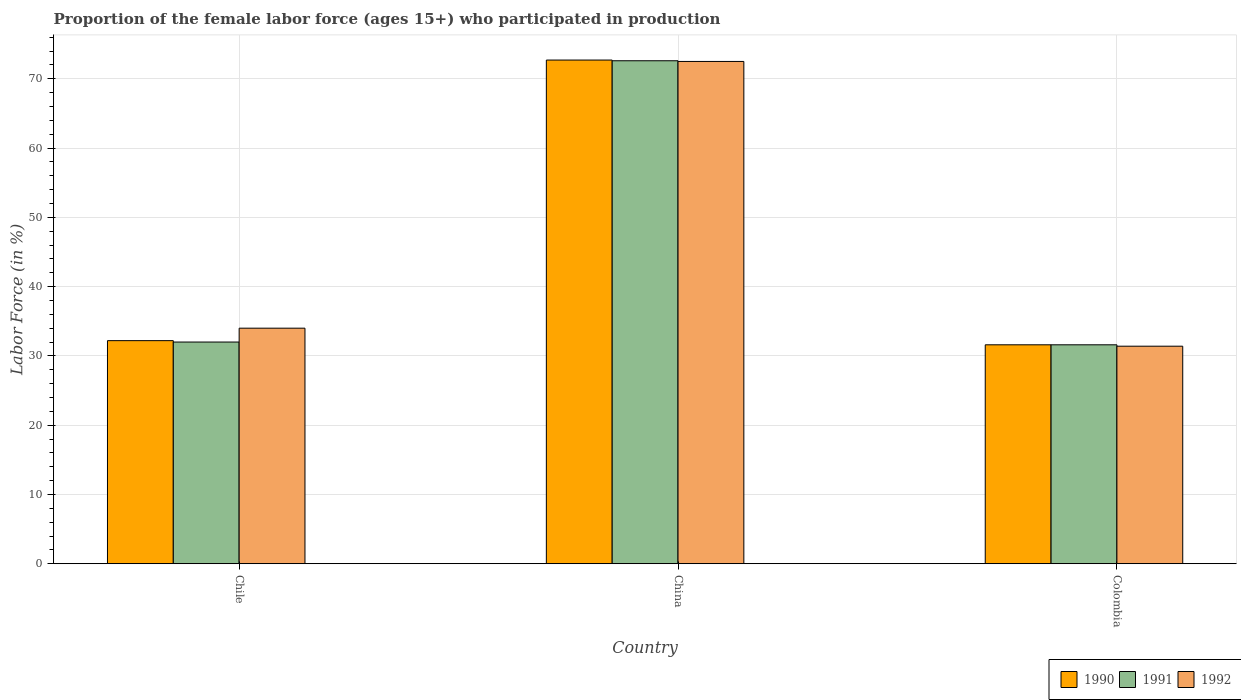Are the number of bars per tick equal to the number of legend labels?
Make the answer very short. Yes. Are the number of bars on each tick of the X-axis equal?
Your answer should be compact. Yes. How many bars are there on the 3rd tick from the right?
Provide a short and direct response. 3. Across all countries, what is the maximum proportion of the female labor force who participated in production in 1992?
Offer a very short reply. 72.5. Across all countries, what is the minimum proportion of the female labor force who participated in production in 1990?
Offer a terse response. 31.6. What is the total proportion of the female labor force who participated in production in 1992 in the graph?
Your answer should be very brief. 137.9. What is the difference between the proportion of the female labor force who participated in production in 1991 in Chile and that in Colombia?
Your response must be concise. 0.4. What is the difference between the proportion of the female labor force who participated in production in 1991 in Chile and the proportion of the female labor force who participated in production in 1992 in China?
Offer a very short reply. -40.5. What is the average proportion of the female labor force who participated in production in 1991 per country?
Your response must be concise. 45.4. What is the difference between the proportion of the female labor force who participated in production of/in 1991 and proportion of the female labor force who participated in production of/in 1992 in Colombia?
Your answer should be compact. 0.2. What is the ratio of the proportion of the female labor force who participated in production in 1991 in Chile to that in China?
Offer a terse response. 0.44. Is the difference between the proportion of the female labor force who participated in production in 1991 in China and Colombia greater than the difference between the proportion of the female labor force who participated in production in 1992 in China and Colombia?
Ensure brevity in your answer.  No. What is the difference between the highest and the second highest proportion of the female labor force who participated in production in 1992?
Your answer should be very brief. 38.5. What is the difference between the highest and the lowest proportion of the female labor force who participated in production in 1991?
Provide a succinct answer. 41. In how many countries, is the proportion of the female labor force who participated in production in 1991 greater than the average proportion of the female labor force who participated in production in 1991 taken over all countries?
Ensure brevity in your answer.  1. Is the sum of the proportion of the female labor force who participated in production in 1992 in China and Colombia greater than the maximum proportion of the female labor force who participated in production in 1991 across all countries?
Your answer should be very brief. Yes. What does the 1st bar from the left in China represents?
Keep it short and to the point. 1990. What does the 1st bar from the right in Chile represents?
Your response must be concise. 1992. How many countries are there in the graph?
Ensure brevity in your answer.  3. Does the graph contain any zero values?
Ensure brevity in your answer.  No. Does the graph contain grids?
Give a very brief answer. Yes. How many legend labels are there?
Provide a short and direct response. 3. How are the legend labels stacked?
Your answer should be very brief. Horizontal. What is the title of the graph?
Provide a succinct answer. Proportion of the female labor force (ages 15+) who participated in production. Does "2015" appear as one of the legend labels in the graph?
Ensure brevity in your answer.  No. What is the label or title of the X-axis?
Make the answer very short. Country. What is the label or title of the Y-axis?
Ensure brevity in your answer.  Labor Force (in %). What is the Labor Force (in %) of 1990 in Chile?
Offer a terse response. 32.2. What is the Labor Force (in %) of 1991 in Chile?
Offer a terse response. 32. What is the Labor Force (in %) of 1992 in Chile?
Provide a succinct answer. 34. What is the Labor Force (in %) in 1990 in China?
Give a very brief answer. 72.7. What is the Labor Force (in %) of 1991 in China?
Make the answer very short. 72.6. What is the Labor Force (in %) of 1992 in China?
Provide a succinct answer. 72.5. What is the Labor Force (in %) of 1990 in Colombia?
Keep it short and to the point. 31.6. What is the Labor Force (in %) in 1991 in Colombia?
Keep it short and to the point. 31.6. What is the Labor Force (in %) in 1992 in Colombia?
Provide a short and direct response. 31.4. Across all countries, what is the maximum Labor Force (in %) in 1990?
Offer a very short reply. 72.7. Across all countries, what is the maximum Labor Force (in %) in 1991?
Offer a very short reply. 72.6. Across all countries, what is the maximum Labor Force (in %) of 1992?
Your answer should be very brief. 72.5. Across all countries, what is the minimum Labor Force (in %) of 1990?
Offer a terse response. 31.6. Across all countries, what is the minimum Labor Force (in %) in 1991?
Ensure brevity in your answer.  31.6. Across all countries, what is the minimum Labor Force (in %) in 1992?
Give a very brief answer. 31.4. What is the total Labor Force (in %) of 1990 in the graph?
Give a very brief answer. 136.5. What is the total Labor Force (in %) of 1991 in the graph?
Your answer should be compact. 136.2. What is the total Labor Force (in %) in 1992 in the graph?
Give a very brief answer. 137.9. What is the difference between the Labor Force (in %) in 1990 in Chile and that in China?
Keep it short and to the point. -40.5. What is the difference between the Labor Force (in %) of 1991 in Chile and that in China?
Offer a terse response. -40.6. What is the difference between the Labor Force (in %) in 1992 in Chile and that in China?
Offer a terse response. -38.5. What is the difference between the Labor Force (in %) in 1991 in Chile and that in Colombia?
Keep it short and to the point. 0.4. What is the difference between the Labor Force (in %) of 1992 in Chile and that in Colombia?
Offer a very short reply. 2.6. What is the difference between the Labor Force (in %) of 1990 in China and that in Colombia?
Ensure brevity in your answer.  41.1. What is the difference between the Labor Force (in %) of 1991 in China and that in Colombia?
Provide a short and direct response. 41. What is the difference between the Labor Force (in %) in 1992 in China and that in Colombia?
Make the answer very short. 41.1. What is the difference between the Labor Force (in %) in 1990 in Chile and the Labor Force (in %) in 1991 in China?
Ensure brevity in your answer.  -40.4. What is the difference between the Labor Force (in %) in 1990 in Chile and the Labor Force (in %) in 1992 in China?
Offer a very short reply. -40.3. What is the difference between the Labor Force (in %) in 1991 in Chile and the Labor Force (in %) in 1992 in China?
Give a very brief answer. -40.5. What is the difference between the Labor Force (in %) in 1990 in Chile and the Labor Force (in %) in 1992 in Colombia?
Keep it short and to the point. 0.8. What is the difference between the Labor Force (in %) in 1991 in Chile and the Labor Force (in %) in 1992 in Colombia?
Make the answer very short. 0.6. What is the difference between the Labor Force (in %) of 1990 in China and the Labor Force (in %) of 1991 in Colombia?
Your answer should be very brief. 41.1. What is the difference between the Labor Force (in %) in 1990 in China and the Labor Force (in %) in 1992 in Colombia?
Provide a succinct answer. 41.3. What is the difference between the Labor Force (in %) of 1991 in China and the Labor Force (in %) of 1992 in Colombia?
Offer a very short reply. 41.2. What is the average Labor Force (in %) of 1990 per country?
Make the answer very short. 45.5. What is the average Labor Force (in %) in 1991 per country?
Make the answer very short. 45.4. What is the average Labor Force (in %) in 1992 per country?
Make the answer very short. 45.97. What is the difference between the Labor Force (in %) of 1990 and Labor Force (in %) of 1992 in China?
Ensure brevity in your answer.  0.2. What is the difference between the Labor Force (in %) in 1991 and Labor Force (in %) in 1992 in China?
Make the answer very short. 0.1. What is the difference between the Labor Force (in %) in 1990 and Labor Force (in %) in 1992 in Colombia?
Your answer should be compact. 0.2. What is the ratio of the Labor Force (in %) of 1990 in Chile to that in China?
Make the answer very short. 0.44. What is the ratio of the Labor Force (in %) of 1991 in Chile to that in China?
Offer a terse response. 0.44. What is the ratio of the Labor Force (in %) in 1992 in Chile to that in China?
Your answer should be very brief. 0.47. What is the ratio of the Labor Force (in %) of 1991 in Chile to that in Colombia?
Your answer should be very brief. 1.01. What is the ratio of the Labor Force (in %) of 1992 in Chile to that in Colombia?
Your answer should be compact. 1.08. What is the ratio of the Labor Force (in %) in 1990 in China to that in Colombia?
Offer a very short reply. 2.3. What is the ratio of the Labor Force (in %) in 1991 in China to that in Colombia?
Your answer should be compact. 2.3. What is the ratio of the Labor Force (in %) in 1992 in China to that in Colombia?
Offer a very short reply. 2.31. What is the difference between the highest and the second highest Labor Force (in %) of 1990?
Give a very brief answer. 40.5. What is the difference between the highest and the second highest Labor Force (in %) of 1991?
Give a very brief answer. 40.6. What is the difference between the highest and the second highest Labor Force (in %) in 1992?
Your response must be concise. 38.5. What is the difference between the highest and the lowest Labor Force (in %) in 1990?
Provide a succinct answer. 41.1. What is the difference between the highest and the lowest Labor Force (in %) of 1991?
Keep it short and to the point. 41. What is the difference between the highest and the lowest Labor Force (in %) in 1992?
Provide a succinct answer. 41.1. 